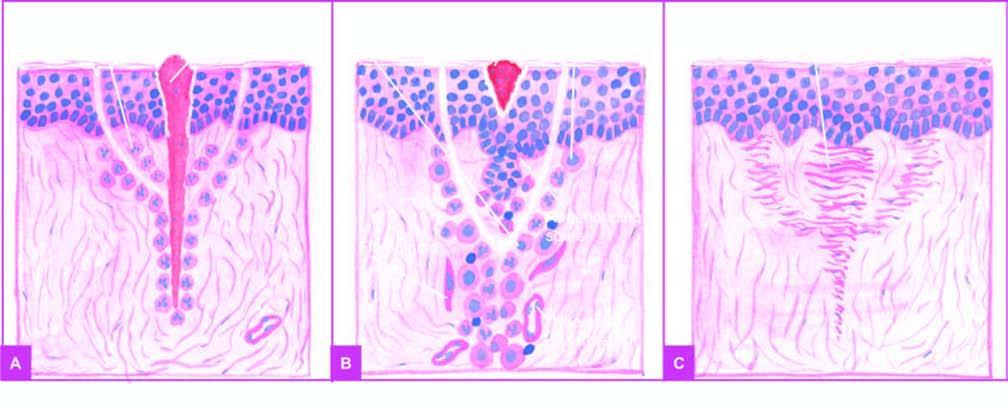do spurs of epidermal cells migrate along the incised margin on either side as well as around the suture track?
Answer the question using a single word or phrase. Yes 